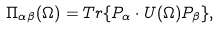<formula> <loc_0><loc_0><loc_500><loc_500>\Pi _ { \alpha \beta } ( \Omega ) = T r \{ P _ { \alpha } \cdot U ( \Omega ) P _ { \beta } \} ,</formula> 